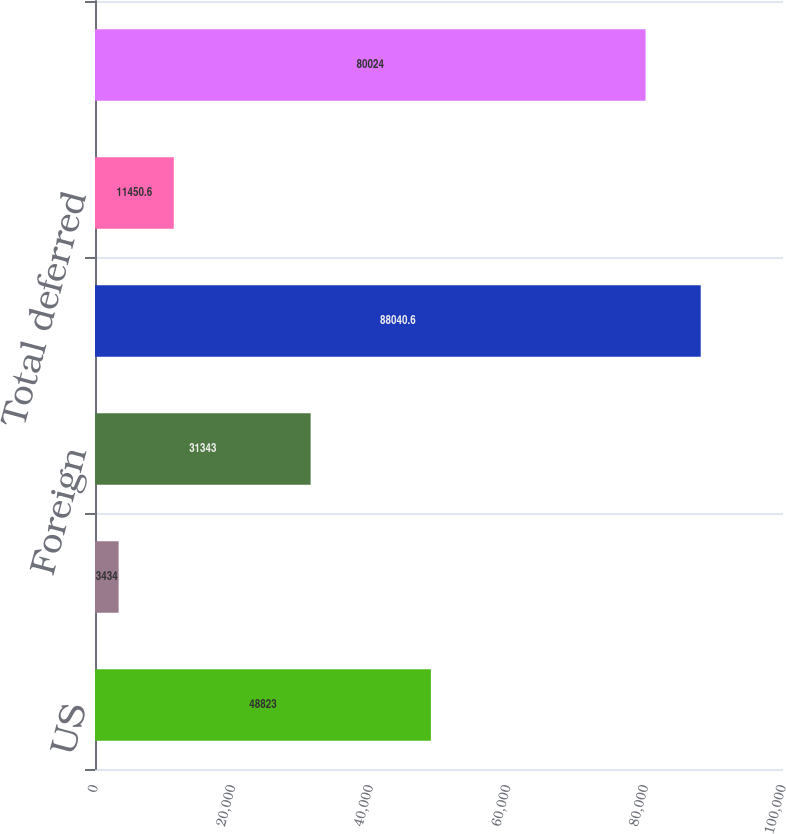<chart> <loc_0><loc_0><loc_500><loc_500><bar_chart><fcel>US<fcel>State and local<fcel>Foreign<fcel>Total current<fcel>Total deferred<fcel>Total provision for income<nl><fcel>48823<fcel>3434<fcel>31343<fcel>88040.6<fcel>11450.6<fcel>80024<nl></chart> 